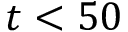<formula> <loc_0><loc_0><loc_500><loc_500>t < 5 0</formula> 